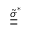<formula> <loc_0><loc_0><loc_500><loc_500>\tilde { \underline { { \underline { \sigma } } } } ^ { * }</formula> 